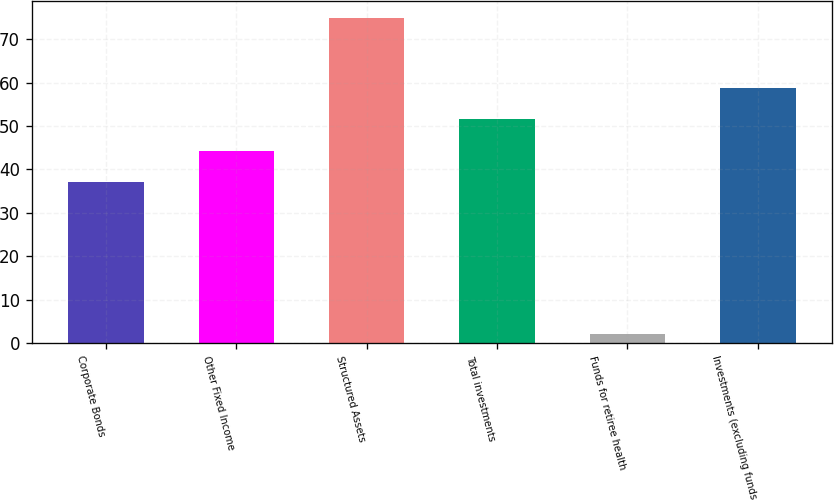Convert chart to OTSL. <chart><loc_0><loc_0><loc_500><loc_500><bar_chart><fcel>Corporate Bonds<fcel>Other Fixed Income<fcel>Structured Assets<fcel>Total investments<fcel>Funds for retiree health<fcel>Investments (excluding funds<nl><fcel>37<fcel>44.3<fcel>75<fcel>51.6<fcel>2<fcel>58.9<nl></chart> 